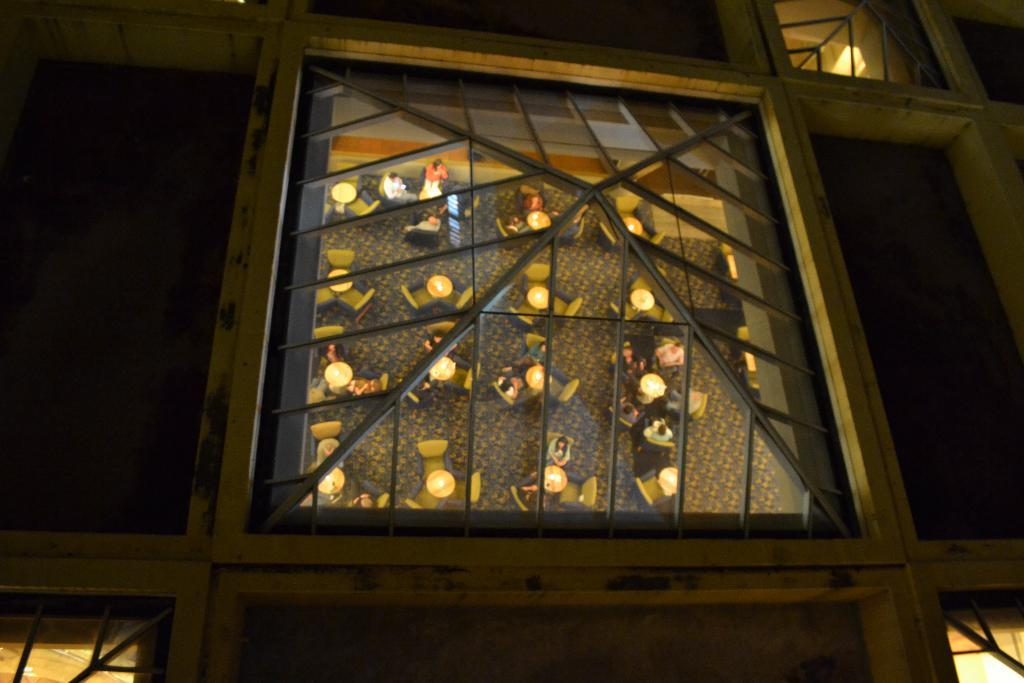What objects are visible in the image? There are lights and metal rods in the image. What can be inferred about the environment based on the background? The background of the image is dark, which might suggest a dimly lit or nighttime setting. What type of vessel is being used by the person sitting on the throne in the image? There is no person sitting on a throne in the image, and therefore no vessel is being used. 